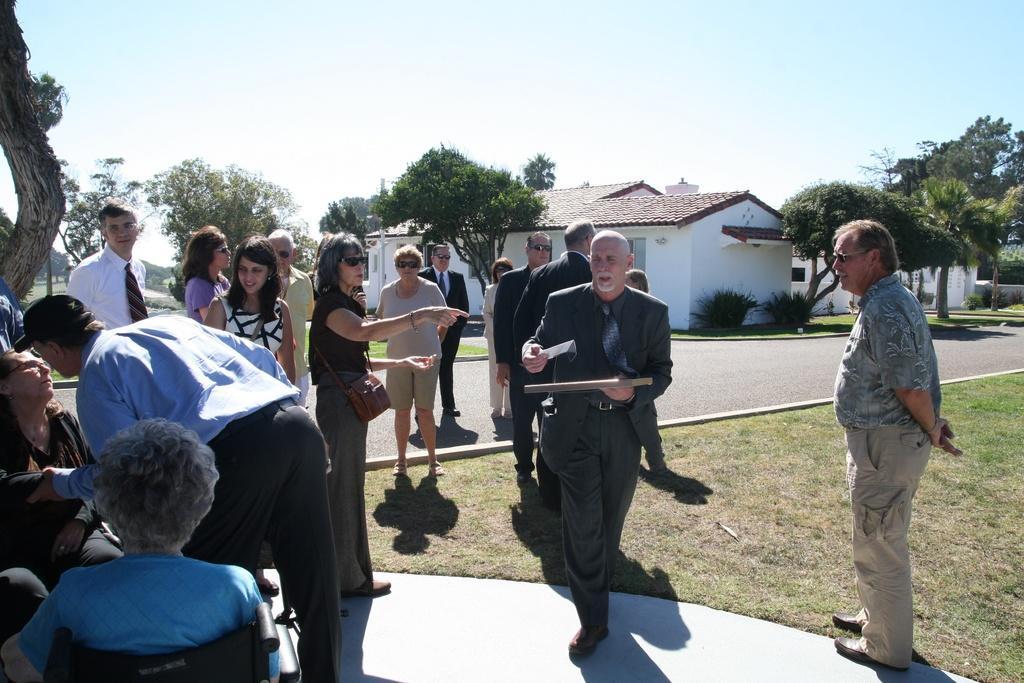In one or two sentences, can you explain what this image depicts? In this image, we can see a group of people. Few are standing and sitting. Here a person is holding some objects and walking. Background there are few houses, trees, plants, grass, roads and sky. 